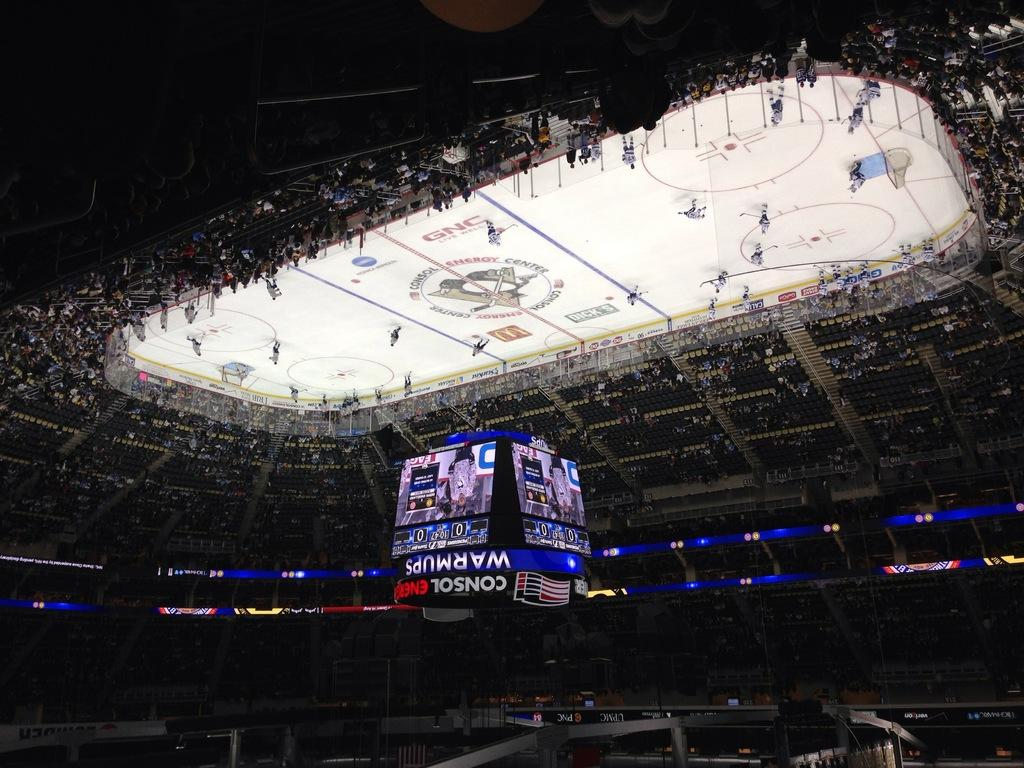<image>
Present a compact description of the photo's key features. A hockey rink with teams playing and a scoreboard overheard advising of warmups. 